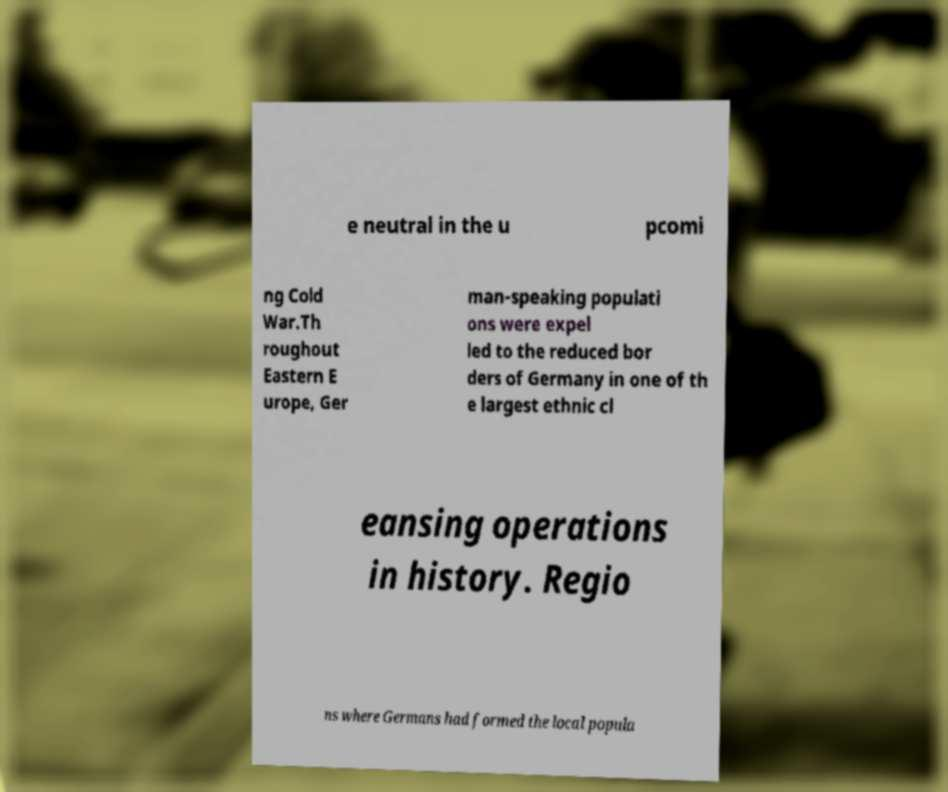Can you read and provide the text displayed in the image?This photo seems to have some interesting text. Can you extract and type it out for me? e neutral in the u pcomi ng Cold War.Th roughout Eastern E urope, Ger man-speaking populati ons were expel led to the reduced bor ders of Germany in one of th e largest ethnic cl eansing operations in history. Regio ns where Germans had formed the local popula 